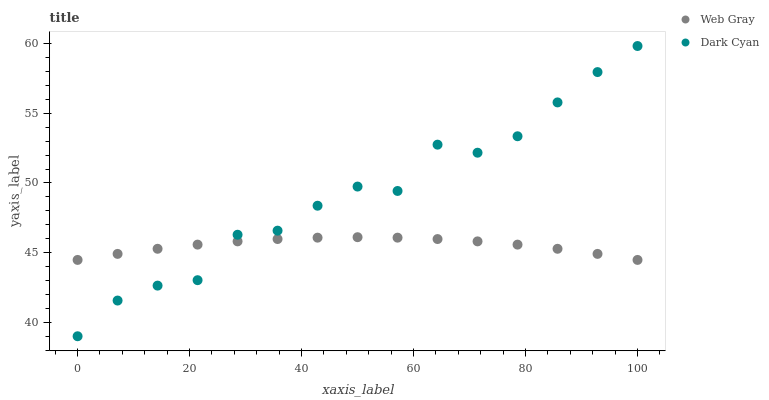Does Web Gray have the minimum area under the curve?
Answer yes or no. Yes. Does Dark Cyan have the maximum area under the curve?
Answer yes or no. Yes. Does Web Gray have the maximum area under the curve?
Answer yes or no. No. Is Web Gray the smoothest?
Answer yes or no. Yes. Is Dark Cyan the roughest?
Answer yes or no. Yes. Is Web Gray the roughest?
Answer yes or no. No. Does Dark Cyan have the lowest value?
Answer yes or no. Yes. Does Web Gray have the lowest value?
Answer yes or no. No. Does Dark Cyan have the highest value?
Answer yes or no. Yes. Does Web Gray have the highest value?
Answer yes or no. No. Does Dark Cyan intersect Web Gray?
Answer yes or no. Yes. Is Dark Cyan less than Web Gray?
Answer yes or no. No. Is Dark Cyan greater than Web Gray?
Answer yes or no. No. 